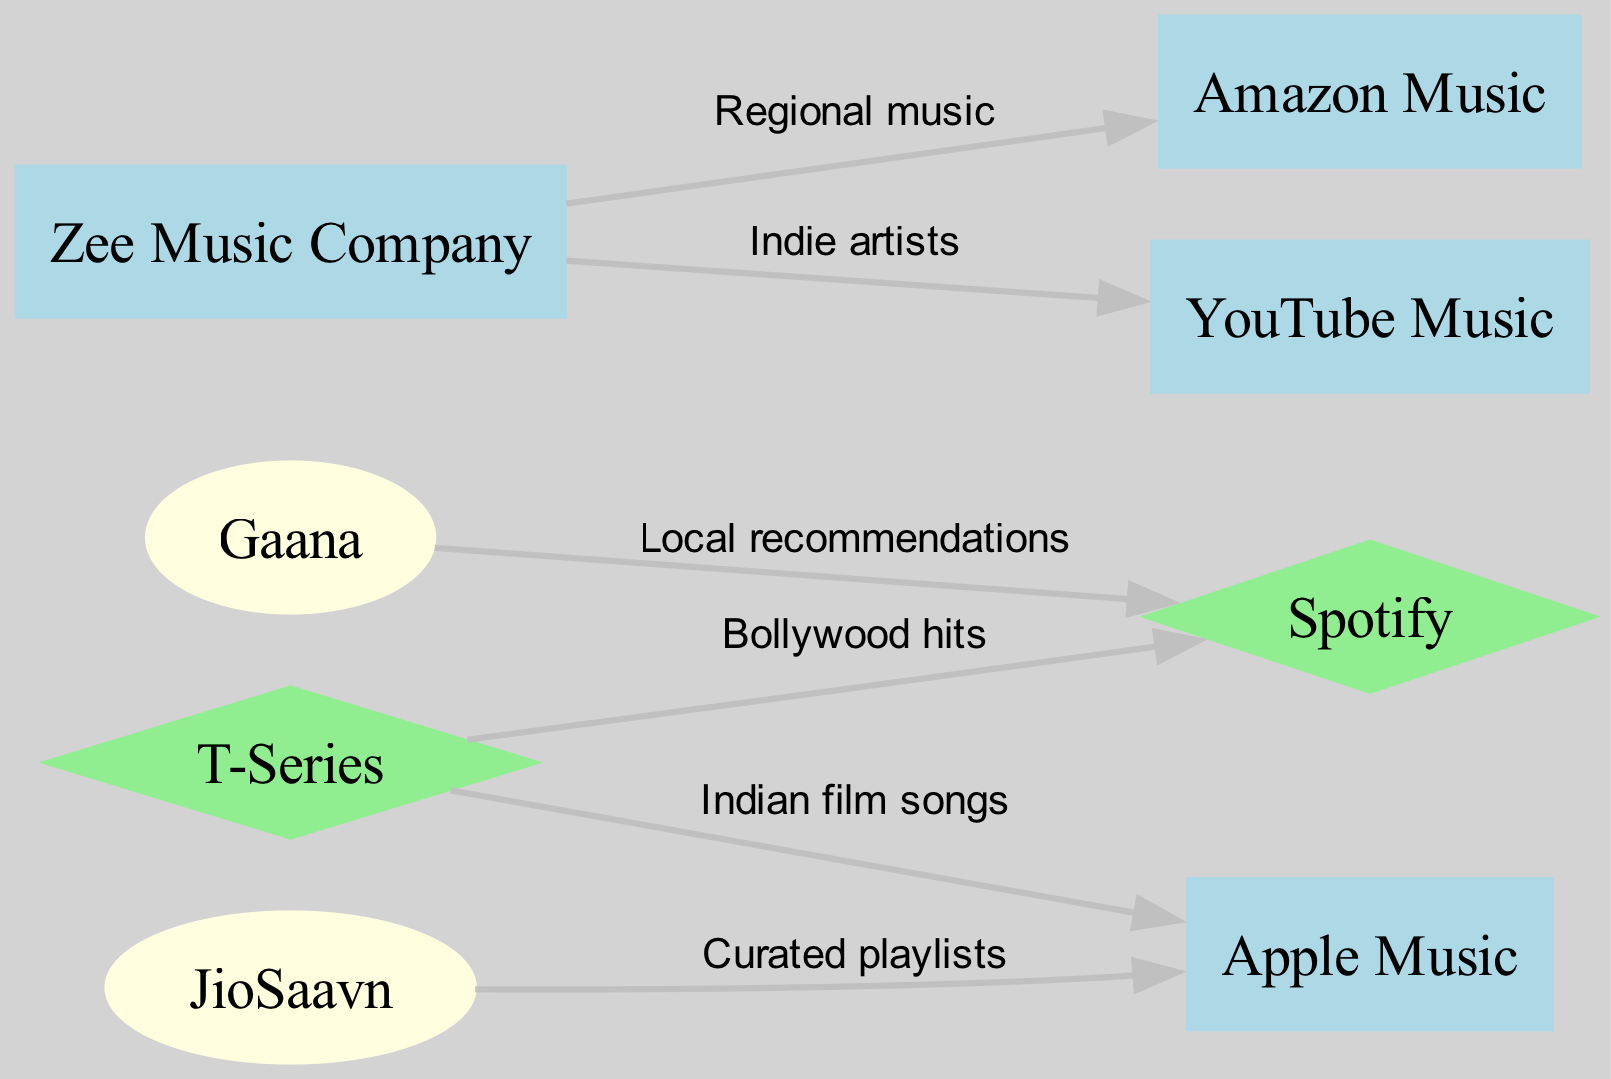What are the nodes in the diagram? The nodes are entities that represent the music streaming platforms and Indian music distributors. By checking the list of nodes provided in the data, we can see that they include Spotify, Apple Music, Amazon Music, Gaana, JioSaavn, T-Series, Zee Music Company, and YouTube Music.
Answer: Spotify, Apple Music, Amazon Music, Gaana, JioSaavn, T-Series, Zee Music Company, YouTube Music How many edges are there in total? Edges indicate the connections or relationships between nodes. By counting the connections listed in the edges section of the data, we find that there are six edges in total, representing the various partnerships or content distribution pathways.
Answer: 6 Which node is connected to YouTube Music? To determine which node connects to YouTube Music, we will look for edges that list YouTube Music as the destination. In the edges, we see that Zee Music Company connects to YouTube Music with the label "Indie artists."
Answer: Zee Music Company What type of music content is distributed from T-Series to Apple Music? Each edge has a label specifying the type of content. Referring to the edge from T-Series to Apple Music, the label indicates "Indian film songs," which tells us the specific type of music being distributed through this connection.
Answer: Indian film songs Which streaming platform is linked to Gaana? Gaana is connected to Spotify according to the edge provided. The edge involving this connection specifies that the type of content distributed is "Local recommendations." We can conclude that Spotify is the platform linked to Gaana.
Answer: Spotify What is the relationship between Zee Music Company and Amazon Music? The edge representing this relationship specifies that the label is "Regional music." This indicates that the content collaboration or distribution from Zee Music Company to Amazon Music revolves around regional music genres or styles.
Answer: Regional music How many music streaming platforms are Indian companies? Indian music platforms identified in the nodes list are Gaana and JioSaavn. These can be counted to determine how many of the specified nodes are Indian companies. There are two Indian streaming platforms.
Answer: 2 Which node represents curated playlists? The edge from JioSaavn to Apple Music indicates that curated playlists are a type of content distribution from JioSaavn to Apple Music. Looking at the edges, we can identify this link explicitly.
Answer: JioSaavn 